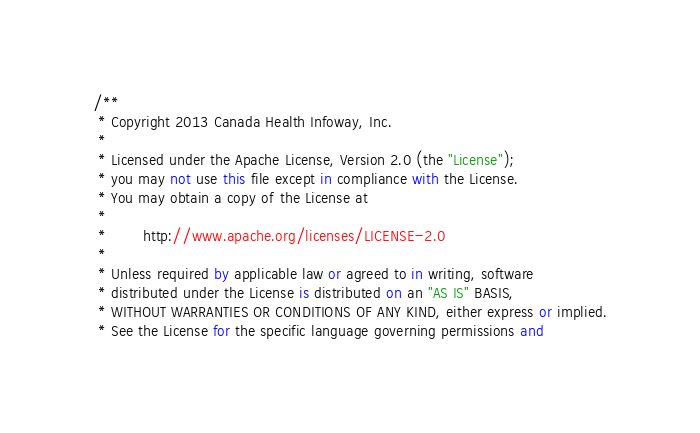Convert code to text. <code><loc_0><loc_0><loc_500><loc_500><_C#_>/**
 * Copyright 2013 Canada Health Infoway, Inc.
 *
 * Licensed under the Apache License, Version 2.0 (the "License");
 * you may not use this file except in compliance with the License.
 * You may obtain a copy of the License at
 *
 *        http://www.apache.org/licenses/LICENSE-2.0
 *
 * Unless required by applicable law or agreed to in writing, software
 * distributed under the License is distributed on an "AS IS" BASIS,
 * WITHOUT WARRANTIES OR CONDITIONS OF ANY KIND, either express or implied.
 * See the License for the specific language governing permissions and</code> 